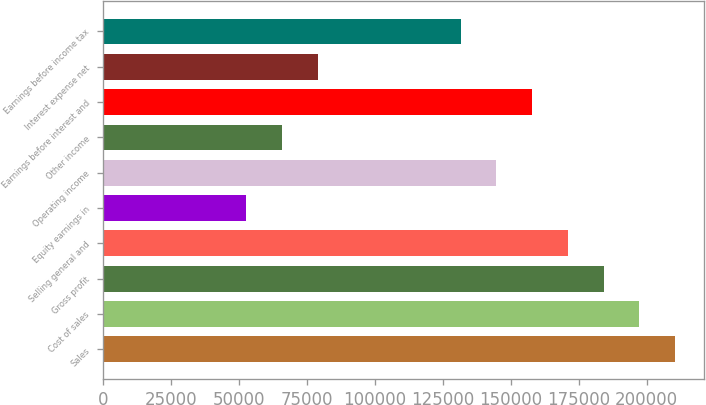<chart> <loc_0><loc_0><loc_500><loc_500><bar_chart><fcel>Sales<fcel>Cost of sales<fcel>Gross profit<fcel>Selling general and<fcel>Equity earnings in<fcel>Operating income<fcel>Other income<fcel>Earnings before interest and<fcel>Interest expense net<fcel>Earnings before income tax<nl><fcel>210456<fcel>197303<fcel>184150<fcel>170997<fcel>52617.8<fcel>144690<fcel>65771<fcel>157843<fcel>78924.2<fcel>131537<nl></chart> 